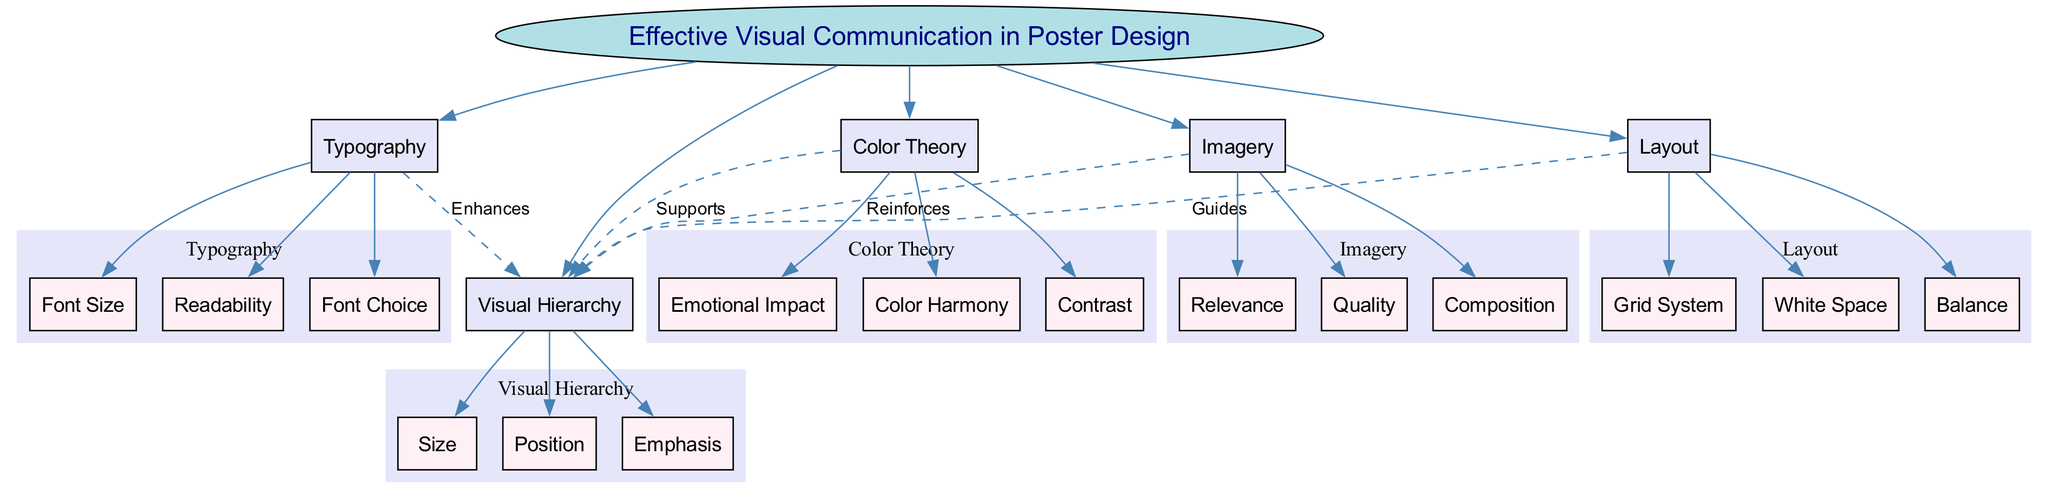What is the central concept of the diagram? The central concept is explicitly labeled and is the main focus of the diagram. Reviewing the central node, it clearly states "Effective Visual Communication in Poster Design."
Answer: Effective Visual Communication in Poster Design How many main elements are identified in the diagram? The main elements are shown branching directly from the central concept. Counting each of these branches gives us a total number of five distinct main elements.
Answer: 5 What sub-element is associated with Layout? The diagram details the sub-elements associated with each main element. For Layout, one of the sub-elements listed is "Grid System."
Answer: Grid System Which main element enhances Visual Hierarchy? The diagram indicates relationships between main elements and Visual Hierarchy. The sub-element "Typography" is labeled as enhancing Visual Hierarchy, and thus it is the correct answer.
Answer: Typography What type of line connects Color Theory to Visual Hierarchy? The relationship between Color Theory and Visual Hierarchy is described in the diagram. The edge connecting them is specifically labeled as "Supports," indicating its type.
Answer: Supports How does Imagery reinforce Visual Hierarchy according to the diagram? The diagram shows a direct connection and indicates that Imagery reinforces Visual Hierarchy. The term "Reinforces" attached to their connection defines this relationship effectively.
Answer: Reinforces What role does White Space play in Layout? The diagram outlines the sub-elements under Layout, one of which is White Space. While the diagram does not specify its role in detail, it is listed as a component of Layout.
Answer: White Space What connects Typography and Visual Hierarchy? The diagram illustrates relationships among various elements. It shows that Typography enhances Visual Hierarchy, making the connection clear.
Answer: Enhances What elements support the Visual Hierarchy? Multiple elements are indicated within the diagram as supporting Visual Hierarchy. These include Layout, Typography, Color Theory, and Imagery, all contributing to this concept.
Answer: Layout, Typography, Color Theory, Imagery How many sub-elements are listed under Color Theory? The diagram specifies that Color Theory comprises three sub-elements. Counting each sub-element under Color Theory gives us the total: Color Harmony, Contrast, and Emotional Impact.
Answer: 3 